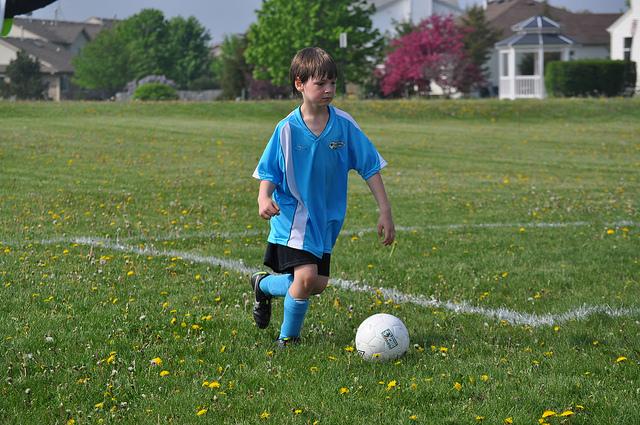Is green in the photo?
Concise answer only. Yes. What foot is the child primarily standing on?
Short answer required. Right. What color are the boy's socks?
Concise answer only. Blue. 